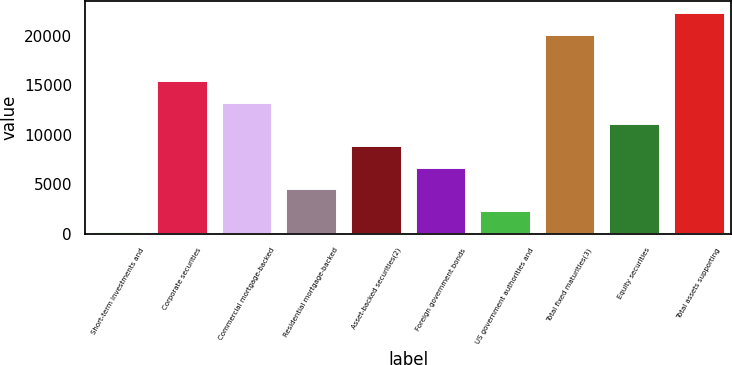Convert chart. <chart><loc_0><loc_0><loc_500><loc_500><bar_chart><fcel>Short-term investments and<fcel>Corporate securities<fcel>Commercial mortgage-backed<fcel>Residential mortgage-backed<fcel>Asset-backed securities(2)<fcel>Foreign government bonds<fcel>US government authorities and<fcel>Total fixed maturities(3)<fcel>Equity securities<fcel>Total assets supporting<nl><fcel>245<fcel>15541.4<fcel>13356.2<fcel>4615.4<fcel>8985.8<fcel>6800.6<fcel>2430.2<fcel>20209<fcel>11171<fcel>22394.2<nl></chart> 